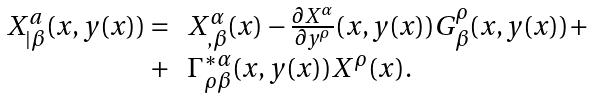<formula> <loc_0><loc_0><loc_500><loc_500>\begin{array} { r l } X ^ { a } _ { | \beta } ( x , y ( x ) ) = & X ^ { \alpha } _ { , \beta } ( x ) - \frac { \partial X ^ { \alpha } } { \partial y ^ { \rho } } ( x , y ( x ) ) G ^ { \rho } _ { \beta } ( x , y ( x ) ) + \\ + & \Gamma ^ { * \alpha } _ { \rho \beta } ( x , y ( x ) ) X ^ { \rho } ( x ) . \end{array}</formula> 